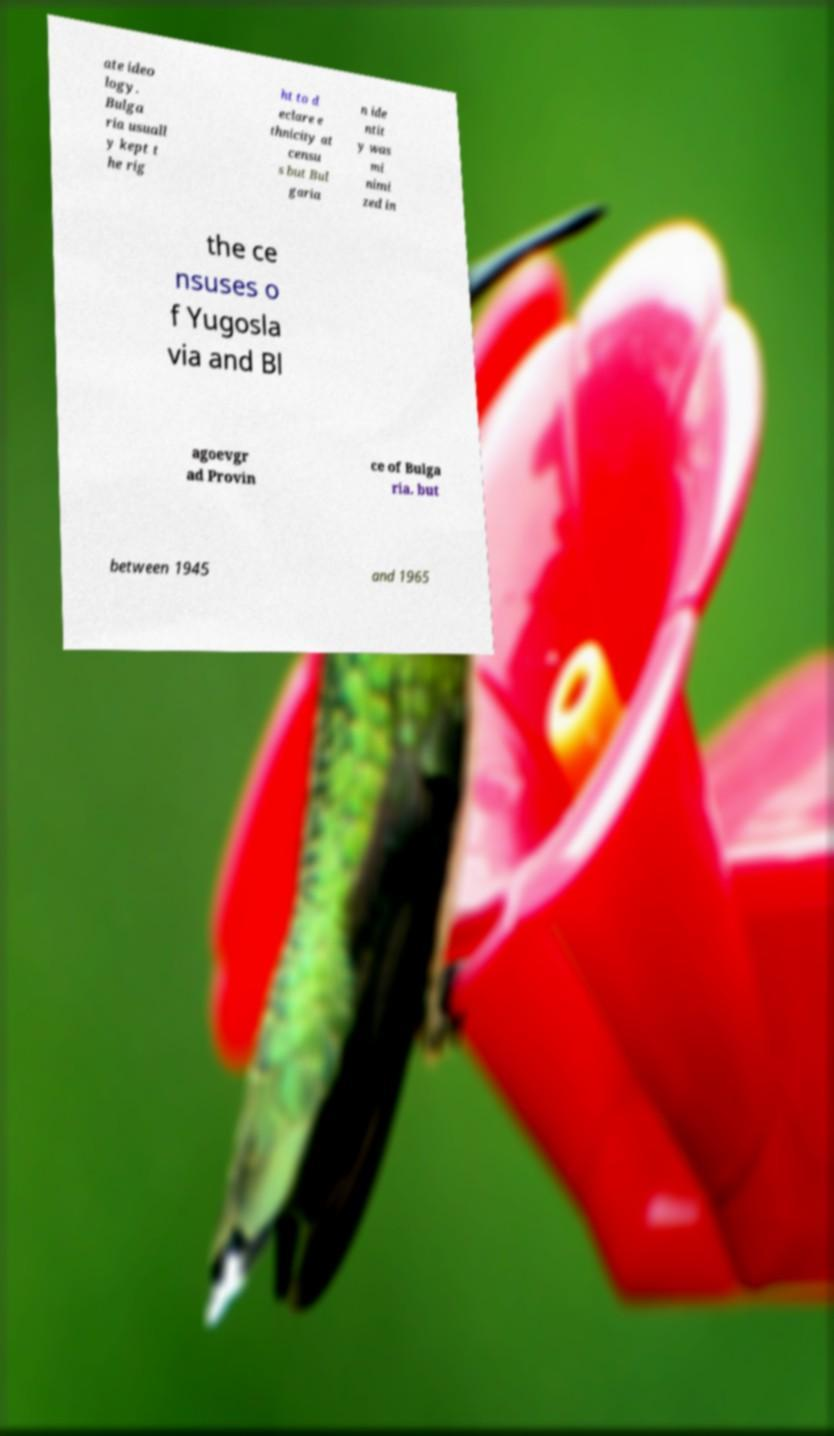What messages or text are displayed in this image? I need them in a readable, typed format. ate ideo logy. Bulga ria usuall y kept t he rig ht to d eclare e thnicity at censu s but Bul garia n ide ntit y was mi nimi zed in the ce nsuses o f Yugosla via and Bl agoevgr ad Provin ce of Bulga ria. but between 1945 and 1965 